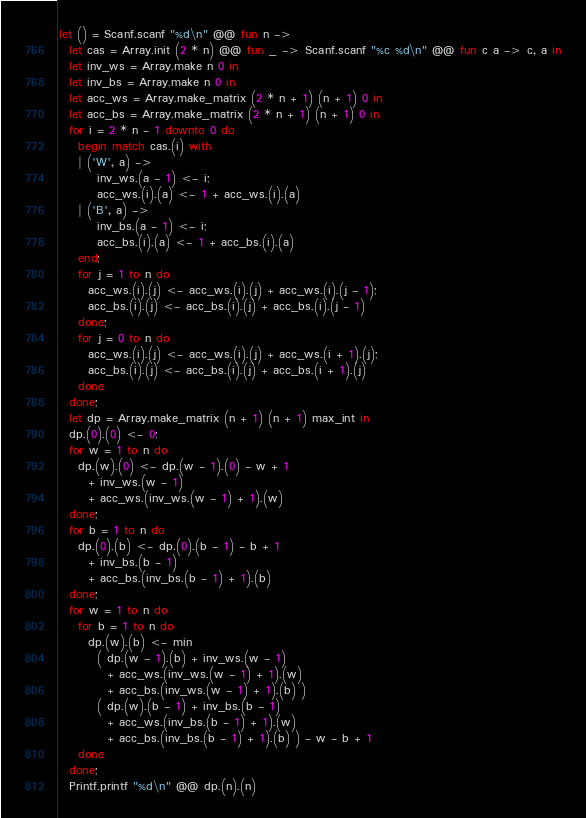<code> <loc_0><loc_0><loc_500><loc_500><_OCaml_>let () = Scanf.scanf "%d\n" @@ fun n ->
  let cas = Array.init (2 * n) @@ fun _ -> Scanf.scanf "%c %d\n" @@ fun c a -> c, a in
  let inv_ws = Array.make n 0 in
  let inv_bs = Array.make n 0 in
  let acc_ws = Array.make_matrix (2 * n + 1) (n + 1) 0 in
  let acc_bs = Array.make_matrix (2 * n + 1) (n + 1) 0 in
  for i = 2 * n - 1 downto 0 do
    begin match cas.(i) with
    | ('W', a) ->
        inv_ws.(a - 1) <- i;
        acc_ws.(i).(a) <- 1 + acc_ws.(i).(a)
    | ('B', a) ->
        inv_bs.(a - 1) <- i;
        acc_bs.(i).(a) <- 1 + acc_bs.(i).(a)
    end;
    for j = 1 to n do
      acc_ws.(i).(j) <- acc_ws.(i).(j) + acc_ws.(i).(j - 1);
      acc_bs.(i).(j) <- acc_bs.(i).(j) + acc_bs.(i).(j - 1)
    done;
    for j = 0 to n do
      acc_ws.(i).(j) <- acc_ws.(i).(j) + acc_ws.(i + 1).(j);
      acc_bs.(i).(j) <- acc_bs.(i).(j) + acc_bs.(i + 1).(j)
    done
  done;
  let dp = Array.make_matrix (n + 1) (n + 1) max_int in
  dp.(0).(0) <- 0;
  for w = 1 to n do
    dp.(w).(0) <- dp.(w - 1).(0) - w + 1
      + inv_ws.(w - 1)
      + acc_ws.(inv_ws.(w - 1) + 1).(w)
  done;
  for b = 1 to n do
    dp.(0).(b) <- dp.(0).(b - 1) - b + 1
      + inv_bs.(b - 1)
      + acc_bs.(inv_bs.(b - 1) + 1).(b)
  done;
  for w = 1 to n do
    for b = 1 to n do
      dp.(w).(b) <- min
        ( dp.(w - 1).(b) + inv_ws.(w - 1)
          + acc_ws.(inv_ws.(w - 1) + 1).(w)
          + acc_bs.(inv_ws.(w - 1) + 1).(b) )
        ( dp.(w).(b - 1) + inv_bs.(b - 1)
          + acc_ws.(inv_bs.(b - 1) + 1).(w)
          + acc_bs.(inv_bs.(b - 1) + 1).(b) ) - w - b + 1
    done
  done;
  Printf.printf "%d\n" @@ dp.(n).(n)
</code> 